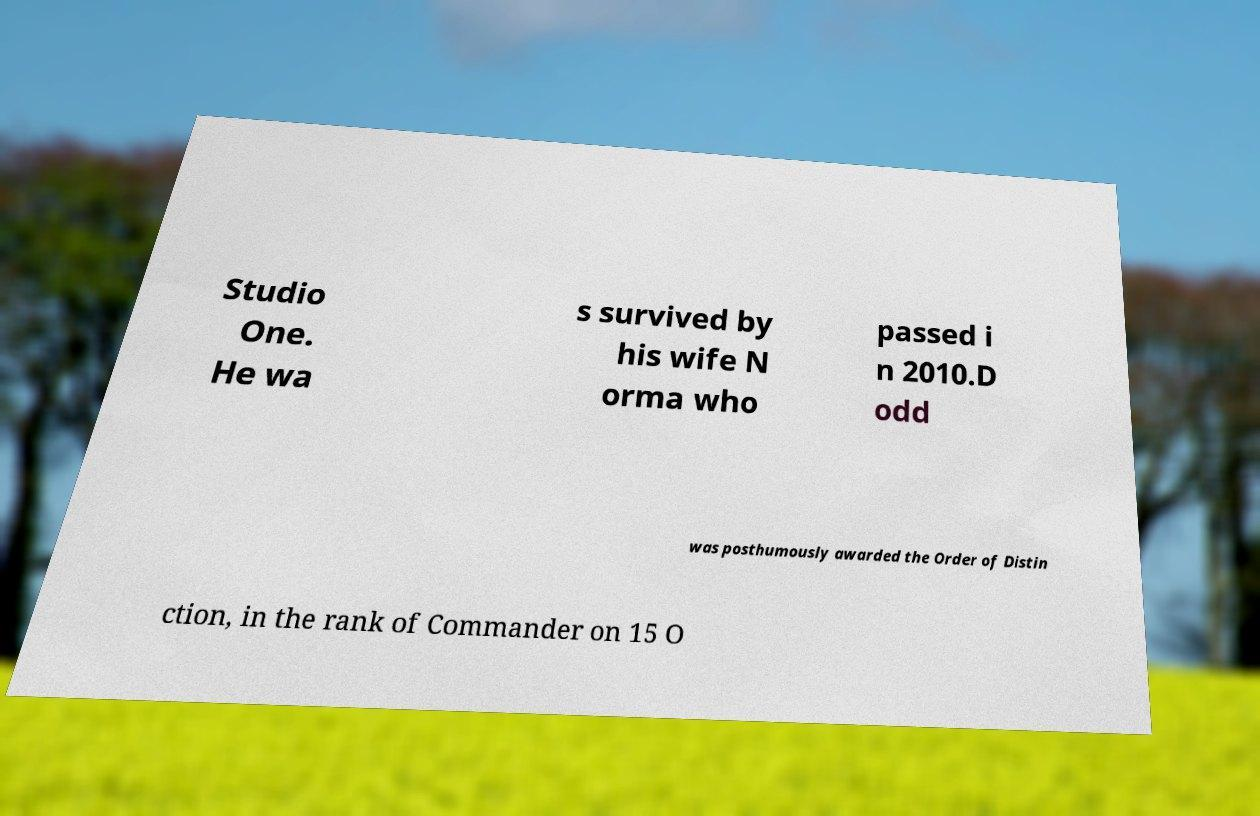Please read and relay the text visible in this image. What does it say? Studio One. He wa s survived by his wife N orma who passed i n 2010.D odd was posthumously awarded the Order of Distin ction, in the rank of Commander on 15 O 